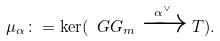Convert formula to latex. <formula><loc_0><loc_0><loc_500><loc_500>\mu _ { \alpha } \colon = \ker ( \ G G _ { m } \xrightarrow { \alpha ^ { \vee } } T ) .</formula> 